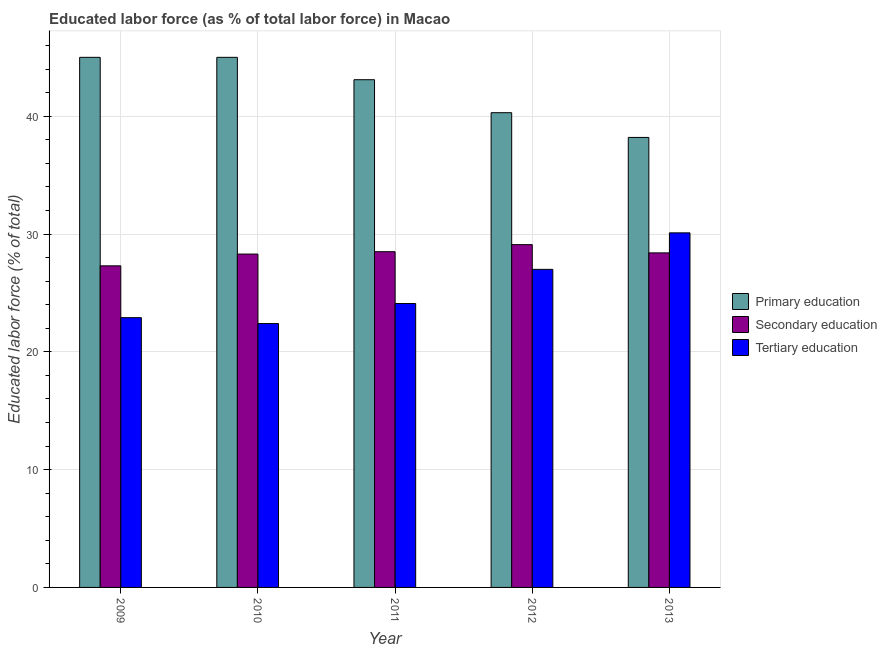Are the number of bars per tick equal to the number of legend labels?
Provide a short and direct response. Yes. Are the number of bars on each tick of the X-axis equal?
Your answer should be compact. Yes. How many bars are there on the 3rd tick from the left?
Offer a very short reply. 3. How many bars are there on the 3rd tick from the right?
Your answer should be compact. 3. What is the label of the 5th group of bars from the left?
Make the answer very short. 2013. What is the percentage of labor force who received primary education in 2012?
Your answer should be very brief. 40.3. Across all years, what is the minimum percentage of labor force who received secondary education?
Make the answer very short. 27.3. In which year was the percentage of labor force who received secondary education maximum?
Your answer should be very brief. 2012. What is the total percentage of labor force who received primary education in the graph?
Offer a very short reply. 211.6. What is the difference between the percentage of labor force who received secondary education in 2009 and that in 2011?
Make the answer very short. -1.2. What is the difference between the percentage of labor force who received primary education in 2011 and the percentage of labor force who received tertiary education in 2009?
Offer a terse response. -1.9. What is the average percentage of labor force who received primary education per year?
Ensure brevity in your answer.  42.32. In the year 2010, what is the difference between the percentage of labor force who received secondary education and percentage of labor force who received tertiary education?
Provide a short and direct response. 0. What is the ratio of the percentage of labor force who received tertiary education in 2009 to that in 2011?
Offer a very short reply. 0.95. Is the percentage of labor force who received primary education in 2009 less than that in 2012?
Provide a short and direct response. No. Is the difference between the percentage of labor force who received tertiary education in 2009 and 2010 greater than the difference between the percentage of labor force who received secondary education in 2009 and 2010?
Your response must be concise. No. What is the difference between the highest and the second highest percentage of labor force who received tertiary education?
Provide a succinct answer. 3.1. What is the difference between the highest and the lowest percentage of labor force who received secondary education?
Your answer should be very brief. 1.8. In how many years, is the percentage of labor force who received tertiary education greater than the average percentage of labor force who received tertiary education taken over all years?
Your answer should be very brief. 2. What does the 3rd bar from the left in 2011 represents?
Offer a terse response. Tertiary education. What does the 3rd bar from the right in 2009 represents?
Your answer should be very brief. Primary education. Is it the case that in every year, the sum of the percentage of labor force who received primary education and percentage of labor force who received secondary education is greater than the percentage of labor force who received tertiary education?
Keep it short and to the point. Yes. How many years are there in the graph?
Your answer should be very brief. 5. What is the difference between two consecutive major ticks on the Y-axis?
Ensure brevity in your answer.  10. Are the values on the major ticks of Y-axis written in scientific E-notation?
Your answer should be very brief. No. Does the graph contain any zero values?
Your response must be concise. No. Where does the legend appear in the graph?
Your answer should be compact. Center right. What is the title of the graph?
Make the answer very short. Educated labor force (as % of total labor force) in Macao. Does "Female employers" appear as one of the legend labels in the graph?
Keep it short and to the point. No. What is the label or title of the X-axis?
Offer a terse response. Year. What is the label or title of the Y-axis?
Offer a very short reply. Educated labor force (% of total). What is the Educated labor force (% of total) of Secondary education in 2009?
Keep it short and to the point. 27.3. What is the Educated labor force (% of total) in Tertiary education in 2009?
Provide a short and direct response. 22.9. What is the Educated labor force (% of total) of Primary education in 2010?
Your answer should be compact. 45. What is the Educated labor force (% of total) of Secondary education in 2010?
Ensure brevity in your answer.  28.3. What is the Educated labor force (% of total) in Tertiary education in 2010?
Offer a terse response. 22.4. What is the Educated labor force (% of total) in Primary education in 2011?
Your response must be concise. 43.1. What is the Educated labor force (% of total) of Secondary education in 2011?
Offer a terse response. 28.5. What is the Educated labor force (% of total) in Tertiary education in 2011?
Provide a succinct answer. 24.1. What is the Educated labor force (% of total) in Primary education in 2012?
Give a very brief answer. 40.3. What is the Educated labor force (% of total) of Secondary education in 2012?
Make the answer very short. 29.1. What is the Educated labor force (% of total) of Primary education in 2013?
Your answer should be very brief. 38.2. What is the Educated labor force (% of total) in Secondary education in 2013?
Your response must be concise. 28.4. What is the Educated labor force (% of total) in Tertiary education in 2013?
Give a very brief answer. 30.1. Across all years, what is the maximum Educated labor force (% of total) of Primary education?
Provide a succinct answer. 45. Across all years, what is the maximum Educated labor force (% of total) of Secondary education?
Make the answer very short. 29.1. Across all years, what is the maximum Educated labor force (% of total) of Tertiary education?
Provide a succinct answer. 30.1. Across all years, what is the minimum Educated labor force (% of total) of Primary education?
Offer a very short reply. 38.2. Across all years, what is the minimum Educated labor force (% of total) of Secondary education?
Offer a very short reply. 27.3. Across all years, what is the minimum Educated labor force (% of total) in Tertiary education?
Your answer should be very brief. 22.4. What is the total Educated labor force (% of total) of Primary education in the graph?
Give a very brief answer. 211.6. What is the total Educated labor force (% of total) in Secondary education in the graph?
Offer a terse response. 141.6. What is the total Educated labor force (% of total) in Tertiary education in the graph?
Ensure brevity in your answer.  126.5. What is the difference between the Educated labor force (% of total) of Tertiary education in 2009 and that in 2010?
Give a very brief answer. 0.5. What is the difference between the Educated labor force (% of total) in Secondary education in 2009 and that in 2012?
Your answer should be compact. -1.8. What is the difference between the Educated labor force (% of total) in Tertiary education in 2009 and that in 2012?
Ensure brevity in your answer.  -4.1. What is the difference between the Educated labor force (% of total) in Primary education in 2009 and that in 2013?
Provide a short and direct response. 6.8. What is the difference between the Educated labor force (% of total) in Primary education in 2010 and that in 2011?
Your answer should be compact. 1.9. What is the difference between the Educated labor force (% of total) of Tertiary education in 2010 and that in 2011?
Give a very brief answer. -1.7. What is the difference between the Educated labor force (% of total) in Secondary education in 2010 and that in 2012?
Offer a terse response. -0.8. What is the difference between the Educated labor force (% of total) of Primary education in 2010 and that in 2013?
Your response must be concise. 6.8. What is the difference between the Educated labor force (% of total) in Secondary education in 2010 and that in 2013?
Give a very brief answer. -0.1. What is the difference between the Educated labor force (% of total) of Tertiary education in 2010 and that in 2013?
Give a very brief answer. -7.7. What is the difference between the Educated labor force (% of total) in Secondary education in 2011 and that in 2012?
Provide a succinct answer. -0.6. What is the difference between the Educated labor force (% of total) in Primary education in 2011 and that in 2013?
Offer a terse response. 4.9. What is the difference between the Educated labor force (% of total) in Secondary education in 2011 and that in 2013?
Offer a terse response. 0.1. What is the difference between the Educated labor force (% of total) in Tertiary education in 2011 and that in 2013?
Your answer should be very brief. -6. What is the difference between the Educated labor force (% of total) in Secondary education in 2012 and that in 2013?
Your answer should be compact. 0.7. What is the difference between the Educated labor force (% of total) of Primary education in 2009 and the Educated labor force (% of total) of Tertiary education in 2010?
Provide a succinct answer. 22.6. What is the difference between the Educated labor force (% of total) of Secondary education in 2009 and the Educated labor force (% of total) of Tertiary education in 2010?
Your answer should be very brief. 4.9. What is the difference between the Educated labor force (% of total) in Primary education in 2009 and the Educated labor force (% of total) in Tertiary education in 2011?
Provide a succinct answer. 20.9. What is the difference between the Educated labor force (% of total) in Secondary education in 2009 and the Educated labor force (% of total) in Tertiary education in 2011?
Your answer should be compact. 3.2. What is the difference between the Educated labor force (% of total) in Primary education in 2009 and the Educated labor force (% of total) in Secondary education in 2012?
Keep it short and to the point. 15.9. What is the difference between the Educated labor force (% of total) in Secondary education in 2009 and the Educated labor force (% of total) in Tertiary education in 2012?
Make the answer very short. 0.3. What is the difference between the Educated labor force (% of total) of Secondary education in 2009 and the Educated labor force (% of total) of Tertiary education in 2013?
Your response must be concise. -2.8. What is the difference between the Educated labor force (% of total) in Primary education in 2010 and the Educated labor force (% of total) in Secondary education in 2011?
Ensure brevity in your answer.  16.5. What is the difference between the Educated labor force (% of total) in Primary education in 2010 and the Educated labor force (% of total) in Tertiary education in 2011?
Your answer should be very brief. 20.9. What is the difference between the Educated labor force (% of total) of Primary education in 2010 and the Educated labor force (% of total) of Secondary education in 2012?
Your answer should be compact. 15.9. What is the difference between the Educated labor force (% of total) in Primary education in 2010 and the Educated labor force (% of total) in Tertiary education in 2012?
Ensure brevity in your answer.  18. What is the difference between the Educated labor force (% of total) in Primary education in 2010 and the Educated labor force (% of total) in Secondary education in 2013?
Ensure brevity in your answer.  16.6. What is the difference between the Educated labor force (% of total) of Primary education in 2011 and the Educated labor force (% of total) of Secondary education in 2012?
Offer a very short reply. 14. What is the difference between the Educated labor force (% of total) of Secondary education in 2011 and the Educated labor force (% of total) of Tertiary education in 2012?
Keep it short and to the point. 1.5. What is the difference between the Educated labor force (% of total) in Primary education in 2012 and the Educated labor force (% of total) in Tertiary education in 2013?
Give a very brief answer. 10.2. What is the average Educated labor force (% of total) in Primary education per year?
Your response must be concise. 42.32. What is the average Educated labor force (% of total) of Secondary education per year?
Keep it short and to the point. 28.32. What is the average Educated labor force (% of total) in Tertiary education per year?
Your answer should be compact. 25.3. In the year 2009, what is the difference between the Educated labor force (% of total) of Primary education and Educated labor force (% of total) of Tertiary education?
Your response must be concise. 22.1. In the year 2009, what is the difference between the Educated labor force (% of total) of Secondary education and Educated labor force (% of total) of Tertiary education?
Ensure brevity in your answer.  4.4. In the year 2010, what is the difference between the Educated labor force (% of total) of Primary education and Educated labor force (% of total) of Tertiary education?
Provide a succinct answer. 22.6. In the year 2010, what is the difference between the Educated labor force (% of total) in Secondary education and Educated labor force (% of total) in Tertiary education?
Offer a terse response. 5.9. In the year 2011, what is the difference between the Educated labor force (% of total) of Primary education and Educated labor force (% of total) of Tertiary education?
Give a very brief answer. 19. In the year 2012, what is the difference between the Educated labor force (% of total) of Primary education and Educated labor force (% of total) of Tertiary education?
Make the answer very short. 13.3. In the year 2012, what is the difference between the Educated labor force (% of total) in Secondary education and Educated labor force (% of total) in Tertiary education?
Offer a very short reply. 2.1. In the year 2013, what is the difference between the Educated labor force (% of total) of Secondary education and Educated labor force (% of total) of Tertiary education?
Give a very brief answer. -1.7. What is the ratio of the Educated labor force (% of total) of Primary education in 2009 to that in 2010?
Make the answer very short. 1. What is the ratio of the Educated labor force (% of total) in Secondary education in 2009 to that in 2010?
Make the answer very short. 0.96. What is the ratio of the Educated labor force (% of total) of Tertiary education in 2009 to that in 2010?
Offer a very short reply. 1.02. What is the ratio of the Educated labor force (% of total) in Primary education in 2009 to that in 2011?
Ensure brevity in your answer.  1.04. What is the ratio of the Educated labor force (% of total) in Secondary education in 2009 to that in 2011?
Offer a terse response. 0.96. What is the ratio of the Educated labor force (% of total) in Tertiary education in 2009 to that in 2011?
Your answer should be very brief. 0.95. What is the ratio of the Educated labor force (% of total) of Primary education in 2009 to that in 2012?
Your answer should be compact. 1.12. What is the ratio of the Educated labor force (% of total) of Secondary education in 2009 to that in 2012?
Keep it short and to the point. 0.94. What is the ratio of the Educated labor force (% of total) in Tertiary education in 2009 to that in 2012?
Your answer should be compact. 0.85. What is the ratio of the Educated labor force (% of total) in Primary education in 2009 to that in 2013?
Your answer should be very brief. 1.18. What is the ratio of the Educated labor force (% of total) in Secondary education in 2009 to that in 2013?
Offer a very short reply. 0.96. What is the ratio of the Educated labor force (% of total) in Tertiary education in 2009 to that in 2013?
Offer a very short reply. 0.76. What is the ratio of the Educated labor force (% of total) of Primary education in 2010 to that in 2011?
Ensure brevity in your answer.  1.04. What is the ratio of the Educated labor force (% of total) in Secondary education in 2010 to that in 2011?
Keep it short and to the point. 0.99. What is the ratio of the Educated labor force (% of total) in Tertiary education in 2010 to that in 2011?
Give a very brief answer. 0.93. What is the ratio of the Educated labor force (% of total) of Primary education in 2010 to that in 2012?
Give a very brief answer. 1.12. What is the ratio of the Educated labor force (% of total) in Secondary education in 2010 to that in 2012?
Make the answer very short. 0.97. What is the ratio of the Educated labor force (% of total) of Tertiary education in 2010 to that in 2012?
Provide a succinct answer. 0.83. What is the ratio of the Educated labor force (% of total) in Primary education in 2010 to that in 2013?
Provide a short and direct response. 1.18. What is the ratio of the Educated labor force (% of total) in Tertiary education in 2010 to that in 2013?
Provide a succinct answer. 0.74. What is the ratio of the Educated labor force (% of total) in Primary education in 2011 to that in 2012?
Offer a very short reply. 1.07. What is the ratio of the Educated labor force (% of total) of Secondary education in 2011 to that in 2012?
Make the answer very short. 0.98. What is the ratio of the Educated labor force (% of total) in Tertiary education in 2011 to that in 2012?
Your response must be concise. 0.89. What is the ratio of the Educated labor force (% of total) in Primary education in 2011 to that in 2013?
Provide a succinct answer. 1.13. What is the ratio of the Educated labor force (% of total) of Secondary education in 2011 to that in 2013?
Provide a short and direct response. 1. What is the ratio of the Educated labor force (% of total) of Tertiary education in 2011 to that in 2013?
Offer a very short reply. 0.8. What is the ratio of the Educated labor force (% of total) of Primary education in 2012 to that in 2013?
Make the answer very short. 1.05. What is the ratio of the Educated labor force (% of total) in Secondary education in 2012 to that in 2013?
Your answer should be very brief. 1.02. What is the ratio of the Educated labor force (% of total) of Tertiary education in 2012 to that in 2013?
Give a very brief answer. 0.9. What is the difference between the highest and the second highest Educated labor force (% of total) in Secondary education?
Your answer should be compact. 0.6. What is the difference between the highest and the lowest Educated labor force (% of total) of Primary education?
Keep it short and to the point. 6.8. What is the difference between the highest and the lowest Educated labor force (% of total) in Tertiary education?
Your response must be concise. 7.7. 